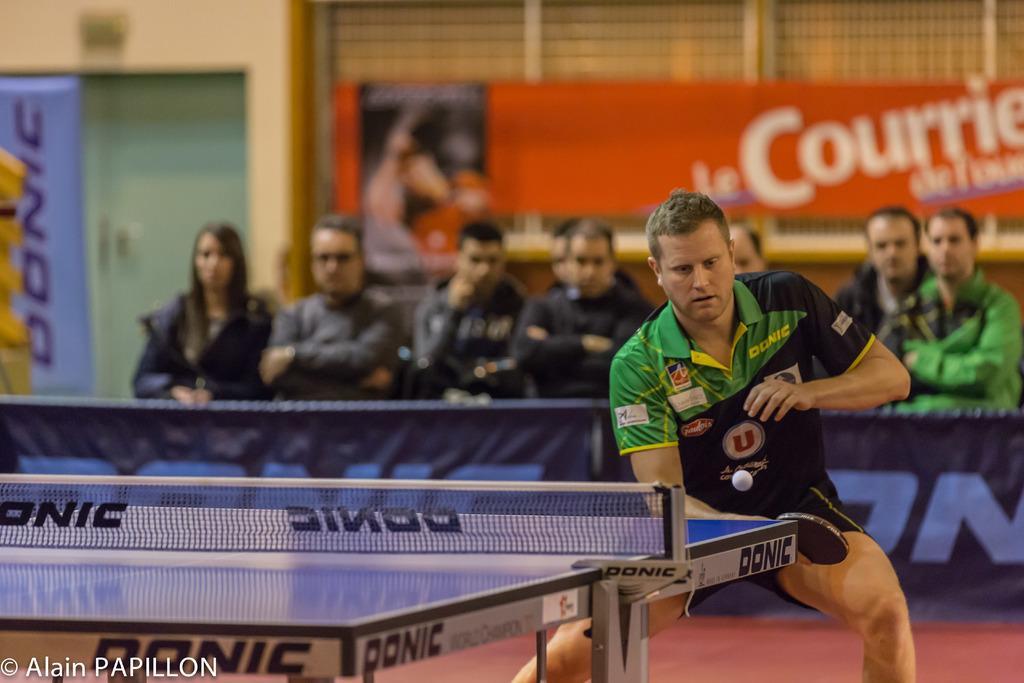In one or two sentences, can you explain what this image depicts? In a picture a person is playing a table tennis and wearing a black t-shirt and behind him there are people sitting in the chairs and behind them there is a wall and door and one poster on it. 